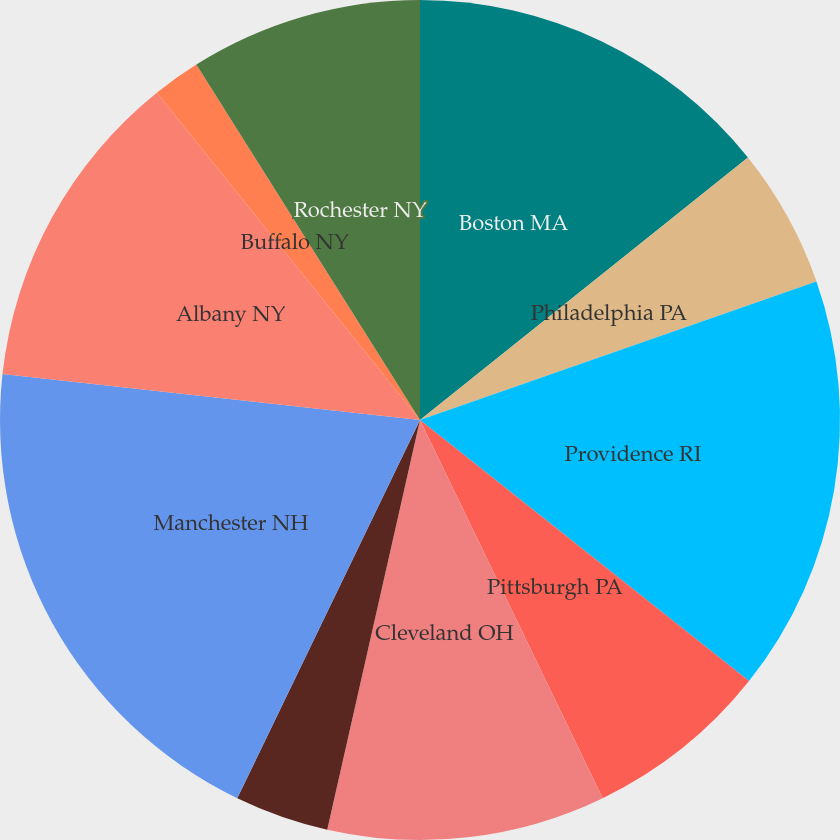<chart> <loc_0><loc_0><loc_500><loc_500><pie_chart><fcel>Boston MA<fcel>Philadelphia PA<fcel>Providence RI<fcel>Pittsburgh PA<fcel>Cleveland OH<fcel>Detroit MI<fcel>Manchester NH<fcel>Albany NY<fcel>Buffalo NY<fcel>Rochester NY<nl><fcel>14.26%<fcel>5.39%<fcel>16.03%<fcel>7.16%<fcel>10.71%<fcel>3.62%<fcel>19.58%<fcel>12.48%<fcel>1.84%<fcel>8.94%<nl></chart> 